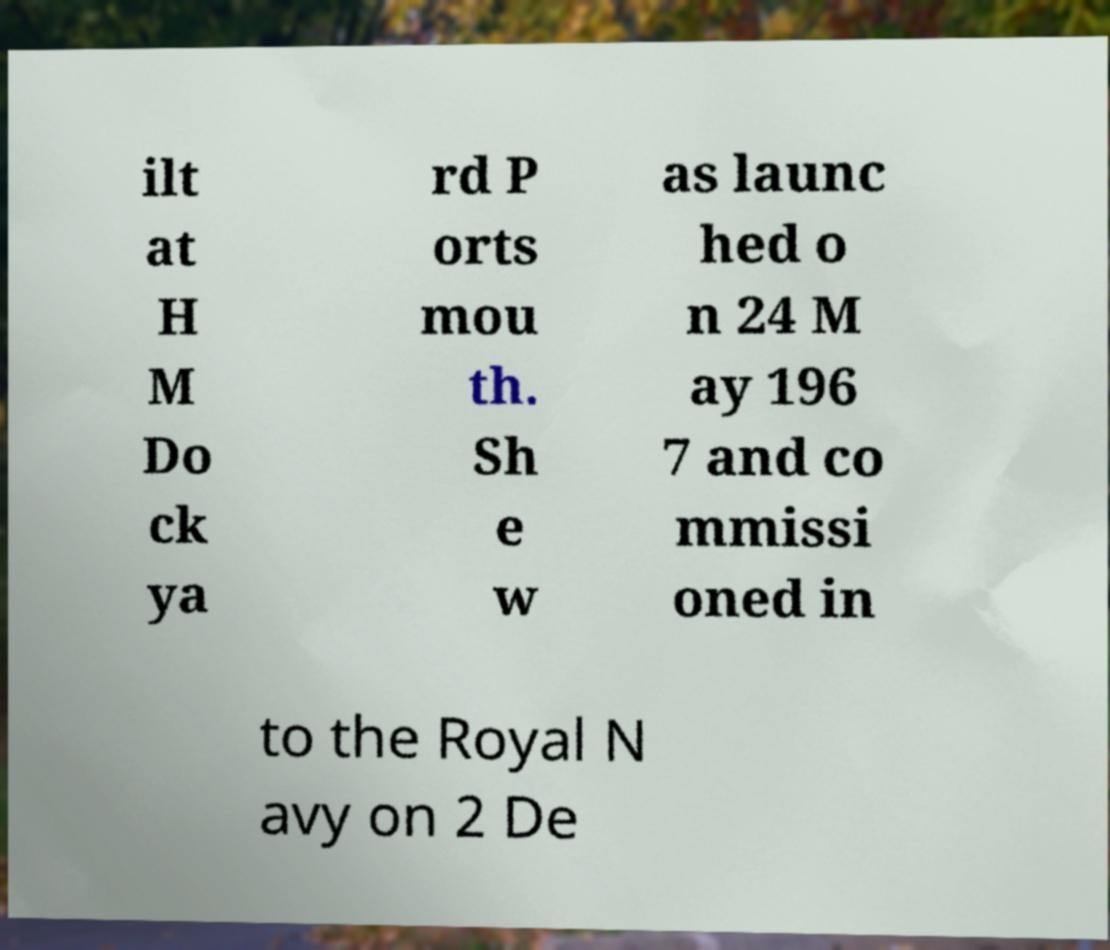I need the written content from this picture converted into text. Can you do that? ilt at H M Do ck ya rd P orts mou th. Sh e w as launc hed o n 24 M ay 196 7 and co mmissi oned in to the Royal N avy on 2 De 